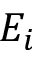Convert formula to latex. <formula><loc_0><loc_0><loc_500><loc_500>E _ { i }</formula> 